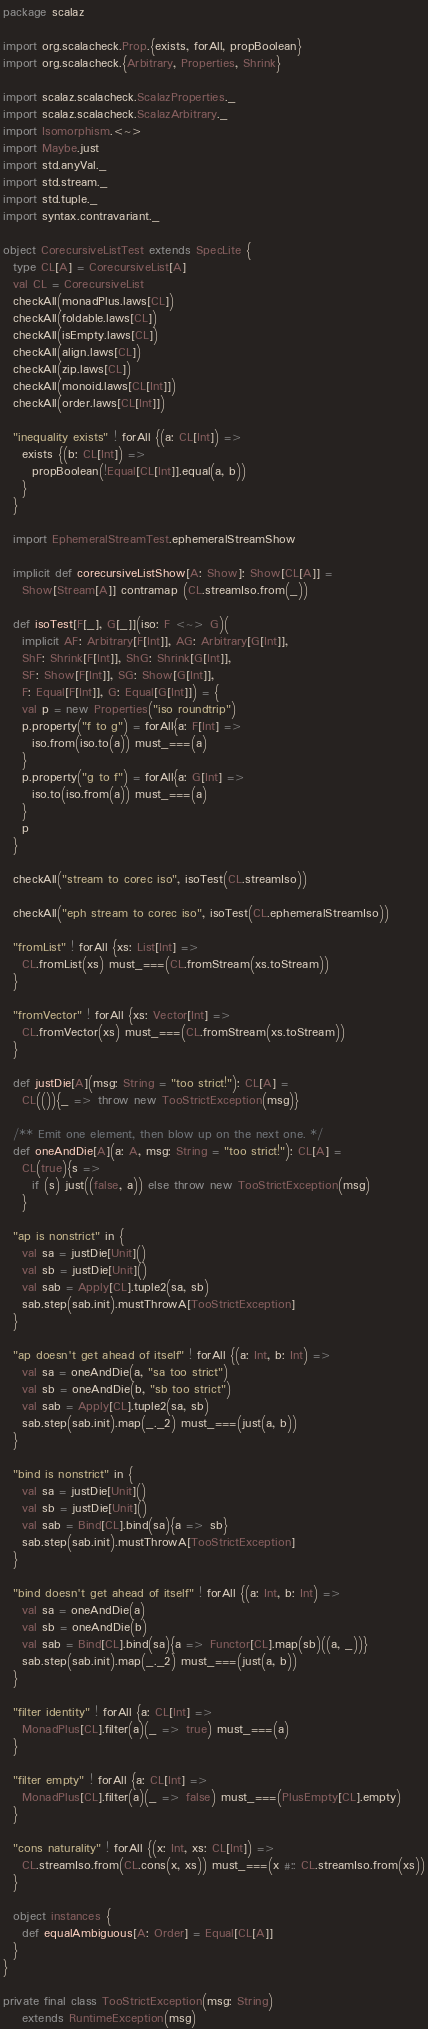<code> <loc_0><loc_0><loc_500><loc_500><_Scala_>package scalaz

import org.scalacheck.Prop.{exists, forAll, propBoolean}
import org.scalacheck.{Arbitrary, Properties, Shrink}

import scalaz.scalacheck.ScalazProperties._
import scalaz.scalacheck.ScalazArbitrary._
import Isomorphism.<~>
import Maybe.just
import std.anyVal._
import std.stream._
import std.tuple._
import syntax.contravariant._

object CorecursiveListTest extends SpecLite {
  type CL[A] = CorecursiveList[A]
  val CL = CorecursiveList
  checkAll(monadPlus.laws[CL])
  checkAll(foldable.laws[CL])
  checkAll(isEmpty.laws[CL])
  checkAll(align.laws[CL])
  checkAll(zip.laws[CL])
  checkAll(monoid.laws[CL[Int]])
  checkAll(order.laws[CL[Int]])

  "inequality exists" ! forAll {(a: CL[Int]) =>
    exists {(b: CL[Int]) =>
      propBoolean(!Equal[CL[Int]].equal(a, b))
    }
  }

  import EphemeralStreamTest.ephemeralStreamShow

  implicit def corecursiveListShow[A: Show]: Show[CL[A]] =
    Show[Stream[A]] contramap (CL.streamIso.from(_))

  def isoTest[F[_], G[_]](iso: F <~> G)(
    implicit AF: Arbitrary[F[Int]], AG: Arbitrary[G[Int]],
    ShF: Shrink[F[Int]], ShG: Shrink[G[Int]],
    SF: Show[F[Int]], SG: Show[G[Int]],
    F: Equal[F[Int]], G: Equal[G[Int]]) = {
    val p = new Properties("iso roundtrip")
    p.property("f to g") = forAll{a: F[Int] =>
      iso.from(iso.to(a)) must_===(a)
    }
    p.property("g to f") = forAll{a: G[Int] =>
      iso.to(iso.from(a)) must_===(a)
    }
    p
  }

  checkAll("stream to corec iso", isoTest(CL.streamIso))

  checkAll("eph stream to corec iso", isoTest(CL.ephemeralStreamIso))

  "fromList" ! forAll {xs: List[Int] =>
    CL.fromList(xs) must_===(CL.fromStream(xs.toStream))
  }

  "fromVector" ! forAll {xs: Vector[Int] =>
    CL.fromVector(xs) must_===(CL.fromStream(xs.toStream))
  }

  def justDie[A](msg: String = "too strict!"): CL[A] =
    CL(()){_ => throw new TooStrictException(msg)}

  /** Emit one element, then blow up on the next one. */
  def oneAndDie[A](a: A, msg: String = "too strict!"): CL[A] =
    CL(true){s =>
      if (s) just((false, a)) else throw new TooStrictException(msg)
    }

  "ap is nonstrict" in {
    val sa = justDie[Unit]()
    val sb = justDie[Unit]()
    val sab = Apply[CL].tuple2(sa, sb)
    sab.step(sab.init).mustThrowA[TooStrictException]
  }

  "ap doesn't get ahead of itself" ! forAll {(a: Int, b: Int) =>
    val sa = oneAndDie(a, "sa too strict")
    val sb = oneAndDie(b, "sb too strict")
    val sab = Apply[CL].tuple2(sa, sb)
    sab.step(sab.init).map(_._2) must_===(just(a, b))
  }

  "bind is nonstrict" in {
    val sa = justDie[Unit]()
    val sb = justDie[Unit]()
    val sab = Bind[CL].bind(sa){a => sb}
    sab.step(sab.init).mustThrowA[TooStrictException]
  }

  "bind doesn't get ahead of itself" ! forAll {(a: Int, b: Int) =>
    val sa = oneAndDie(a)
    val sb = oneAndDie(b)
    val sab = Bind[CL].bind(sa){a => Functor[CL].map(sb)((a, _))}
    sab.step(sab.init).map(_._2) must_===(just(a, b))
  }

  "filter identity" ! forAll {a: CL[Int] =>
    MonadPlus[CL].filter(a)(_ => true) must_===(a)
  }

  "filter empty" ! forAll {a: CL[Int] =>
    MonadPlus[CL].filter(a)(_ => false) must_===(PlusEmpty[CL].empty)
  }

  "cons naturality" ! forAll {(x: Int, xs: CL[Int]) =>
    CL.streamIso.from(CL.cons(x, xs)) must_===(x #:: CL.streamIso.from(xs))
  }

  object instances {
    def equalAmbiguous[A: Order] = Equal[CL[A]]
  }
}

private final class TooStrictException(msg: String)
    extends RuntimeException(msg)
</code> 